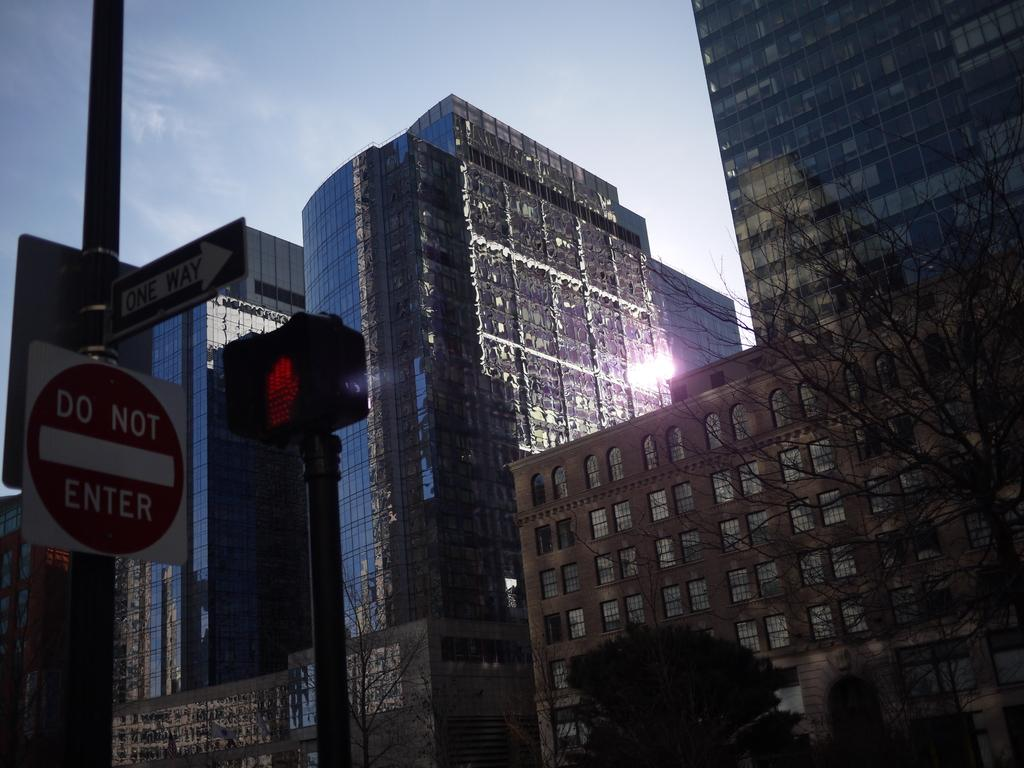What type of structures can be seen in the image? There are buildings in the image. What other objects are present in the image besides buildings? There are sign boards, a traffic light, trees, and other objects in the image. Can you describe the traffic control device in the image? There is a traffic light in the image. What type of vegetation is visible in the image? There are trees in the image. What can be seen in the background of the image? The sky is visible in the background of the image. What type of silver stocking can be seen on the stick in the image? There is no silver stocking or stick present in the image. What color is the silver stocking on the stick in the image? Since there is no silver stocking or stick in the image, we cannot determine its color. 